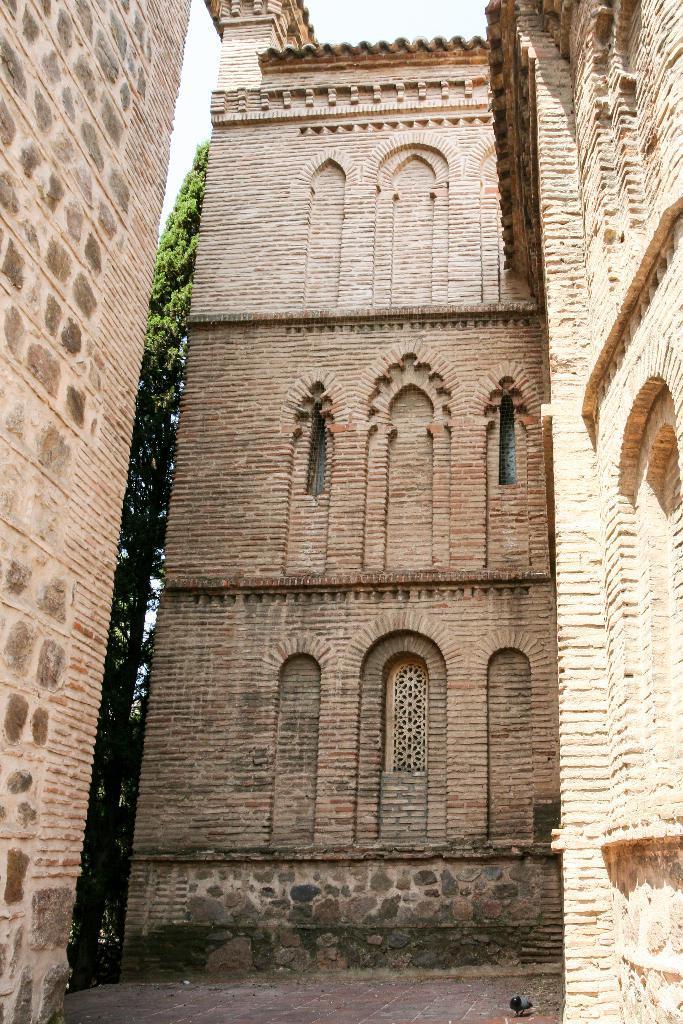How would you summarize this image in a sentence or two? In this image I can see few buildings which are brown in color and few trees. In the background I can see the sky and I can see a bird on the floor. 